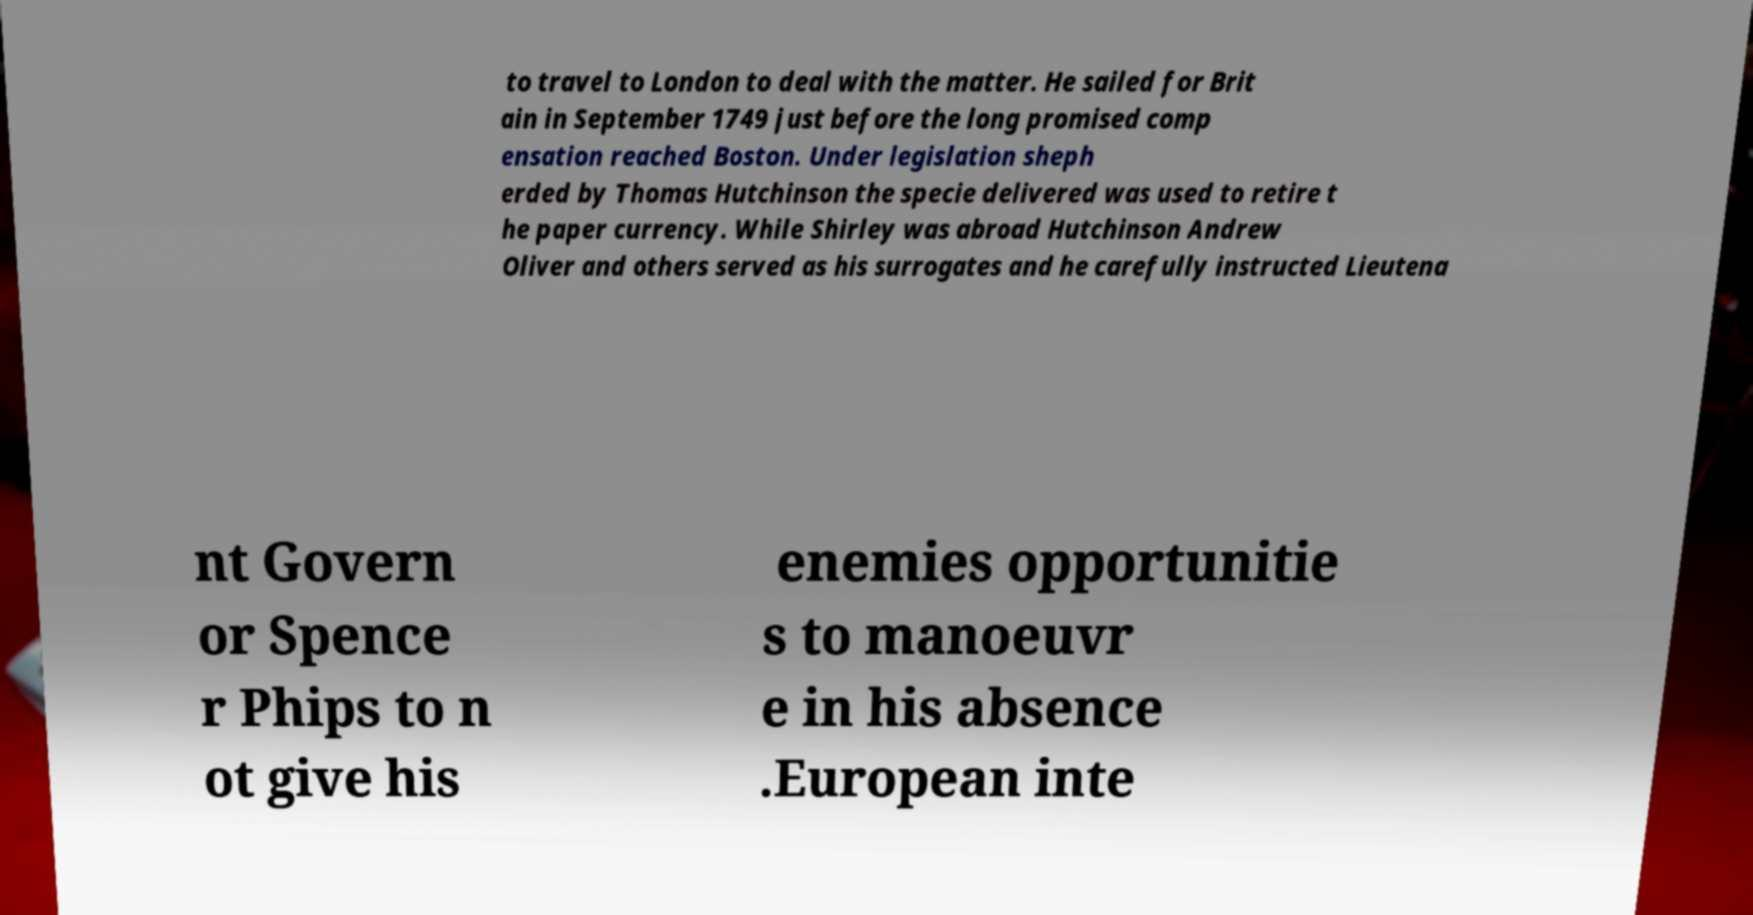There's text embedded in this image that I need extracted. Can you transcribe it verbatim? to travel to London to deal with the matter. He sailed for Brit ain in September 1749 just before the long promised comp ensation reached Boston. Under legislation sheph erded by Thomas Hutchinson the specie delivered was used to retire t he paper currency. While Shirley was abroad Hutchinson Andrew Oliver and others served as his surrogates and he carefully instructed Lieutena nt Govern or Spence r Phips to n ot give his enemies opportunitie s to manoeuvr e in his absence .European inte 